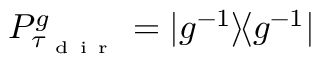<formula> <loc_0><loc_0><loc_500><loc_500>P _ { \tau _ { d i r } } ^ { g } = | g ^ { - 1 } \rangle \, \langle g ^ { - 1 } |</formula> 